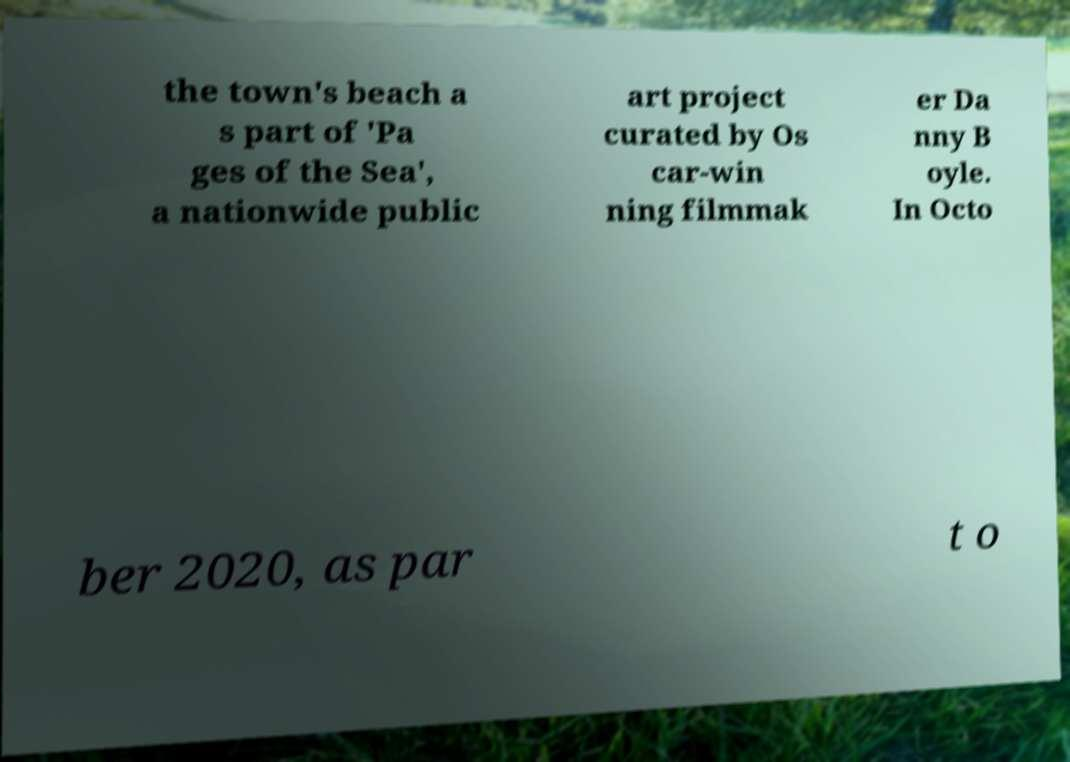Please identify and transcribe the text found in this image. the town's beach a s part of 'Pa ges of the Sea', a nationwide public art project curated by Os car-win ning filmmak er Da nny B oyle. In Octo ber 2020, as par t o 